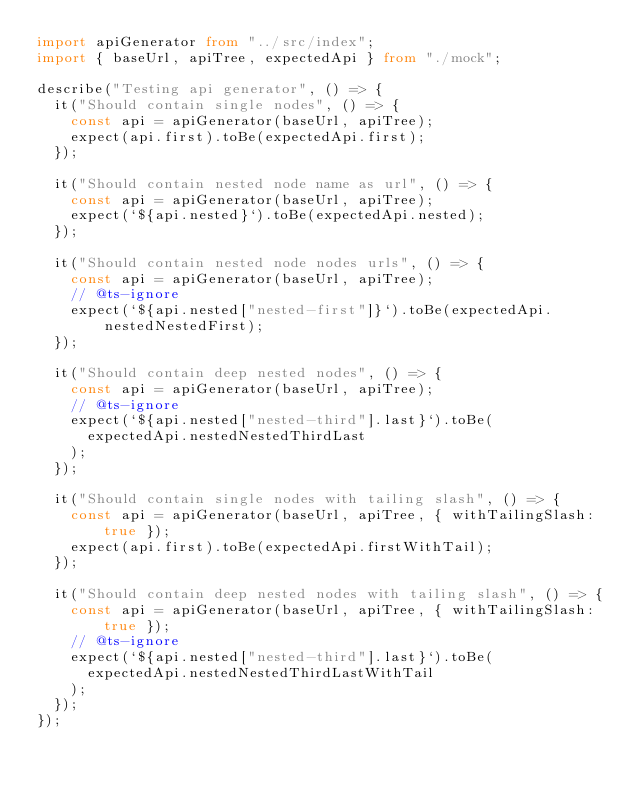<code> <loc_0><loc_0><loc_500><loc_500><_TypeScript_>import apiGenerator from "../src/index";
import { baseUrl, apiTree, expectedApi } from "./mock";

describe("Testing api generator", () => {
  it("Should contain single nodes", () => {
    const api = apiGenerator(baseUrl, apiTree);
    expect(api.first).toBe(expectedApi.first);
  });

  it("Should contain nested node name as url", () => {
    const api = apiGenerator(baseUrl, apiTree);
    expect(`${api.nested}`).toBe(expectedApi.nested);
  });

  it("Should contain nested node nodes urls", () => {
    const api = apiGenerator(baseUrl, apiTree);
    // @ts-ignore
    expect(`${api.nested["nested-first"]}`).toBe(expectedApi.nestedNestedFirst);
  });

  it("Should contain deep nested nodes", () => {
    const api = apiGenerator(baseUrl, apiTree);
    // @ts-ignore
    expect(`${api.nested["nested-third"].last}`).toBe(
      expectedApi.nestedNestedThirdLast
    );
  });

  it("Should contain single nodes with tailing slash", () => {
    const api = apiGenerator(baseUrl, apiTree, { withTailingSlash: true });
    expect(api.first).toBe(expectedApi.firstWithTail);
  });

  it("Should contain deep nested nodes with tailing slash", () => {
    const api = apiGenerator(baseUrl, apiTree, { withTailingSlash: true });
    // @ts-ignore
    expect(`${api.nested["nested-third"].last}`).toBe(
      expectedApi.nestedNestedThirdLastWithTail
    );
  });
});
</code> 